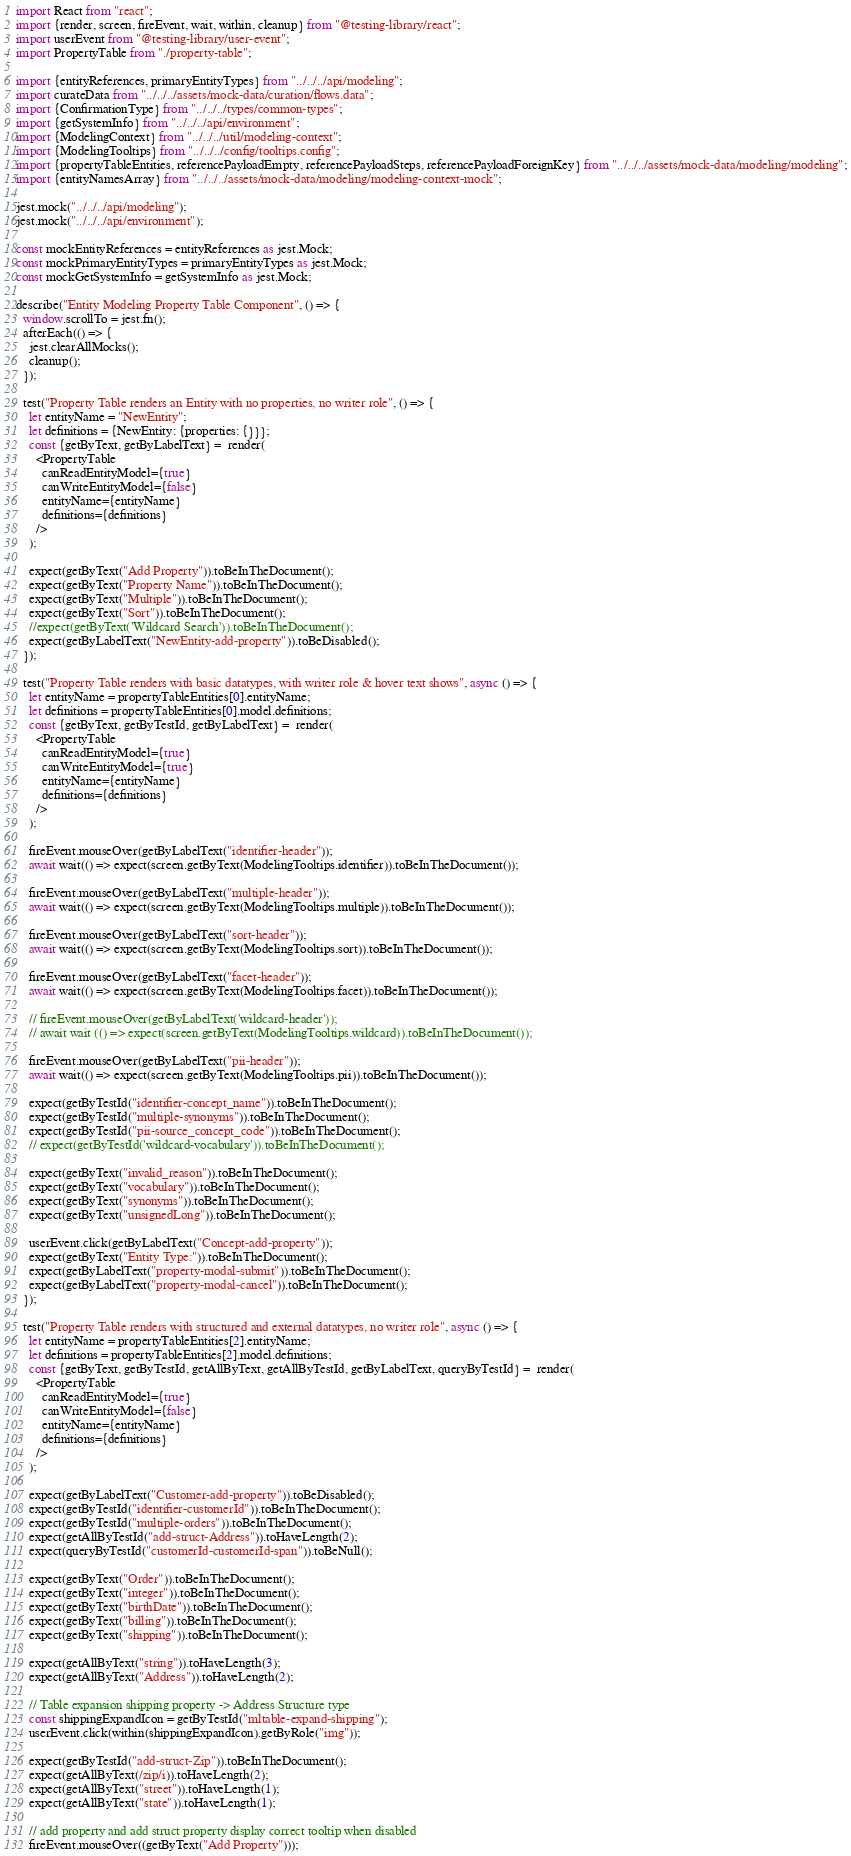Convert code to text. <code><loc_0><loc_0><loc_500><loc_500><_TypeScript_>import React from "react";
import {render, screen, fireEvent, wait, within, cleanup} from "@testing-library/react";
import userEvent from "@testing-library/user-event";
import PropertyTable from "./property-table";

import {entityReferences, primaryEntityTypes} from "../../../api/modeling";
import curateData from "../../../assets/mock-data/curation/flows.data";
import {ConfirmationType} from "../../../types/common-types";
import {getSystemInfo} from "../../../api/environment";
import {ModelingContext} from "../../../util/modeling-context";
import {ModelingTooltips} from "../../../config/tooltips.config";
import {propertyTableEntities, referencePayloadEmpty, referencePayloadSteps, referencePayloadForeignKey} from "../../../assets/mock-data/modeling/modeling";
import {entityNamesArray} from "../../../assets/mock-data/modeling/modeling-context-mock";

jest.mock("../../../api/modeling");
jest.mock("../../../api/environment");

const mockEntityReferences = entityReferences as jest.Mock;
const mockPrimaryEntityTypes = primaryEntityTypes as jest.Mock;
const mockGetSystemInfo = getSystemInfo as jest.Mock;

describe("Entity Modeling Property Table Component", () => {
  window.scrollTo = jest.fn();
  afterEach(() => {
    jest.clearAllMocks();
    cleanup();
  });

  test("Property Table renders an Entity with no properties, no writer role", () => {
    let entityName = "NewEntity";
    let definitions = {NewEntity: {properties: {}}};
    const {getByText, getByLabelText} =  render(
      <PropertyTable
        canReadEntityModel={true}
        canWriteEntityModel={false}
        entityName={entityName}
        definitions={definitions}
      />
    );

    expect(getByText("Add Property")).toBeInTheDocument();
    expect(getByText("Property Name")).toBeInTheDocument();
    expect(getByText("Multiple")).toBeInTheDocument();
    expect(getByText("Sort")).toBeInTheDocument();
    //expect(getByText('Wildcard Search')).toBeInTheDocument();
    expect(getByLabelText("NewEntity-add-property")).toBeDisabled();
  });

  test("Property Table renders with basic datatypes, with writer role & hover text shows", async () => {
    let entityName = propertyTableEntities[0].entityName;
    let definitions = propertyTableEntities[0].model.definitions;
    const {getByText, getByTestId, getByLabelText} =  render(
      <PropertyTable
        canReadEntityModel={true}
        canWriteEntityModel={true}
        entityName={entityName}
        definitions={definitions}
      />
    );

    fireEvent.mouseOver(getByLabelText("identifier-header"));
    await wait(() => expect(screen.getByText(ModelingTooltips.identifier)).toBeInTheDocument());

    fireEvent.mouseOver(getByLabelText("multiple-header"));
    await wait(() => expect(screen.getByText(ModelingTooltips.multiple)).toBeInTheDocument());

    fireEvent.mouseOver(getByLabelText("sort-header"));
    await wait(() => expect(screen.getByText(ModelingTooltips.sort)).toBeInTheDocument());

    fireEvent.mouseOver(getByLabelText("facet-header"));
    await wait(() => expect(screen.getByText(ModelingTooltips.facet)).toBeInTheDocument());

    // fireEvent.mouseOver(getByLabelText('wildcard-header'));
    // await wait (() => expect(screen.getByText(ModelingTooltips.wildcard)).toBeInTheDocument());

    fireEvent.mouseOver(getByLabelText("pii-header"));
    await wait(() => expect(screen.getByText(ModelingTooltips.pii)).toBeInTheDocument());

    expect(getByTestId("identifier-concept_name")).toBeInTheDocument();
    expect(getByTestId("multiple-synonyms")).toBeInTheDocument();
    expect(getByTestId("pii-source_concept_code")).toBeInTheDocument();
    // expect(getByTestId('wildcard-vocabulary')).toBeInTheDocument();

    expect(getByText("invalid_reason")).toBeInTheDocument();
    expect(getByText("vocabulary")).toBeInTheDocument();
    expect(getByText("synonyms")).toBeInTheDocument();
    expect(getByText("unsignedLong")).toBeInTheDocument();

    userEvent.click(getByLabelText("Concept-add-property"));
    expect(getByText("Entity Type:")).toBeInTheDocument();
    expect(getByLabelText("property-modal-submit")).toBeInTheDocument();
    expect(getByLabelText("property-modal-cancel")).toBeInTheDocument();
  });

  test("Property Table renders with structured and external datatypes, no writer role", async () => {
    let entityName = propertyTableEntities[2].entityName;
    let definitions = propertyTableEntities[2].model.definitions;
    const {getByText, getByTestId, getAllByText, getAllByTestId, getByLabelText, queryByTestId} =  render(
      <PropertyTable
        canReadEntityModel={true}
        canWriteEntityModel={false}
        entityName={entityName}
        definitions={definitions}
      />
    );

    expect(getByLabelText("Customer-add-property")).toBeDisabled();
    expect(getByTestId("identifier-customerId")).toBeInTheDocument();
    expect(getByTestId("multiple-orders")).toBeInTheDocument();
    expect(getAllByTestId("add-struct-Address")).toHaveLength(2);
    expect(queryByTestId("customerId-customerId-span")).toBeNull();

    expect(getByText("Order")).toBeInTheDocument();
    expect(getByText("integer")).toBeInTheDocument();
    expect(getByText("birthDate")).toBeInTheDocument();
    expect(getByText("billing")).toBeInTheDocument();
    expect(getByText("shipping")).toBeInTheDocument();

    expect(getAllByText("string")).toHaveLength(3);
    expect(getAllByText("Address")).toHaveLength(2);

    // Table expansion shipping property -> Address Structure type
    const shippingExpandIcon = getByTestId("mltable-expand-shipping");
    userEvent.click(within(shippingExpandIcon).getByRole("img"));

    expect(getByTestId("add-struct-Zip")).toBeInTheDocument();
    expect(getAllByText(/zip/i)).toHaveLength(2);
    expect(getAllByText("street")).toHaveLength(1);
    expect(getAllByText("state")).toHaveLength(1);

    // add property and add struct property display correct tooltip when disabled
    fireEvent.mouseOver((getByText("Add Property")));</code> 